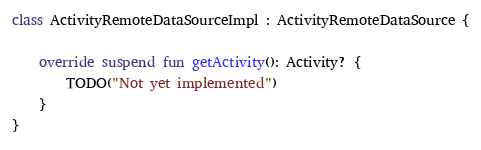<code> <loc_0><loc_0><loc_500><loc_500><_Kotlin_>
class ActivityRemoteDataSourceImpl : ActivityRemoteDataSource {

    override suspend fun getActivity(): Activity? {
        TODO("Not yet implemented")
    }
}
</code> 